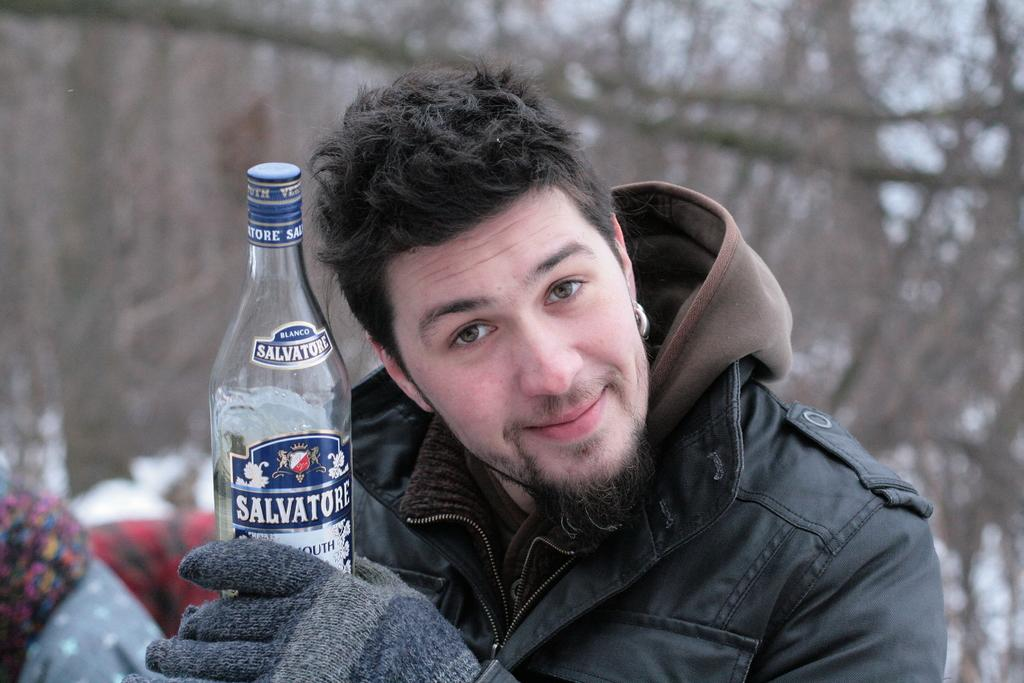What is present in the image? There is a man in the image. What is the man holding in his hand? The man is holding a bottle in his hand. Where is the cart located in the image? There is no cart present in the image. 